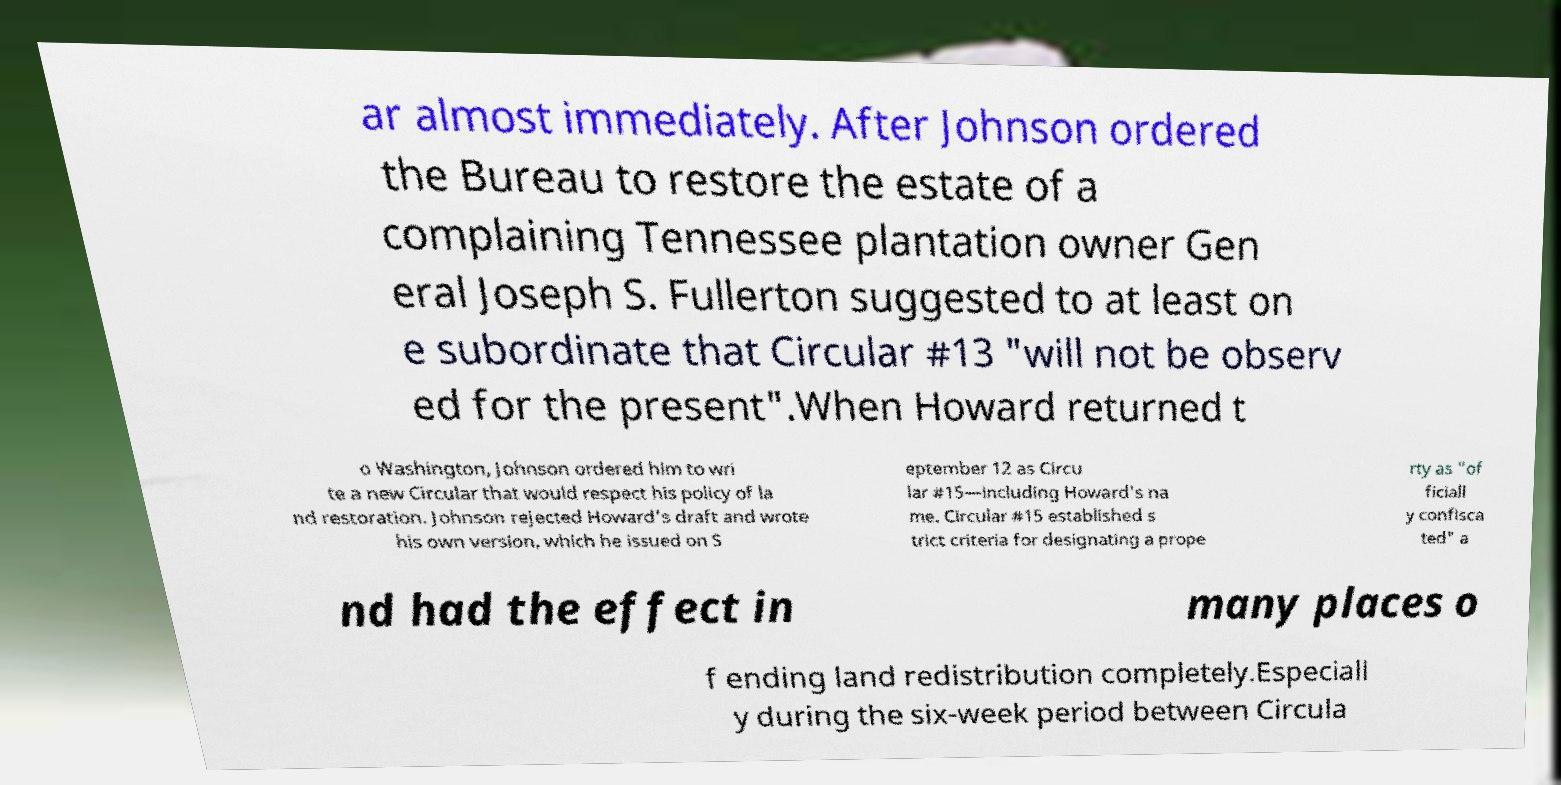For documentation purposes, I need the text within this image transcribed. Could you provide that? ar almost immediately. After Johnson ordered the Bureau to restore the estate of a complaining Tennessee plantation owner Gen eral Joseph S. Fullerton suggested to at least on e subordinate that Circular #13 "will not be observ ed for the present".When Howard returned t o Washington, Johnson ordered him to wri te a new Circular that would respect his policy of la nd restoration. Johnson rejected Howard's draft and wrote his own version, which he issued on S eptember 12 as Circu lar #15—including Howard's na me. Circular #15 established s trict criteria for designating a prope rty as "of ficiall y confisca ted" a nd had the effect in many places o f ending land redistribution completely.Especiall y during the six-week period between Circula 